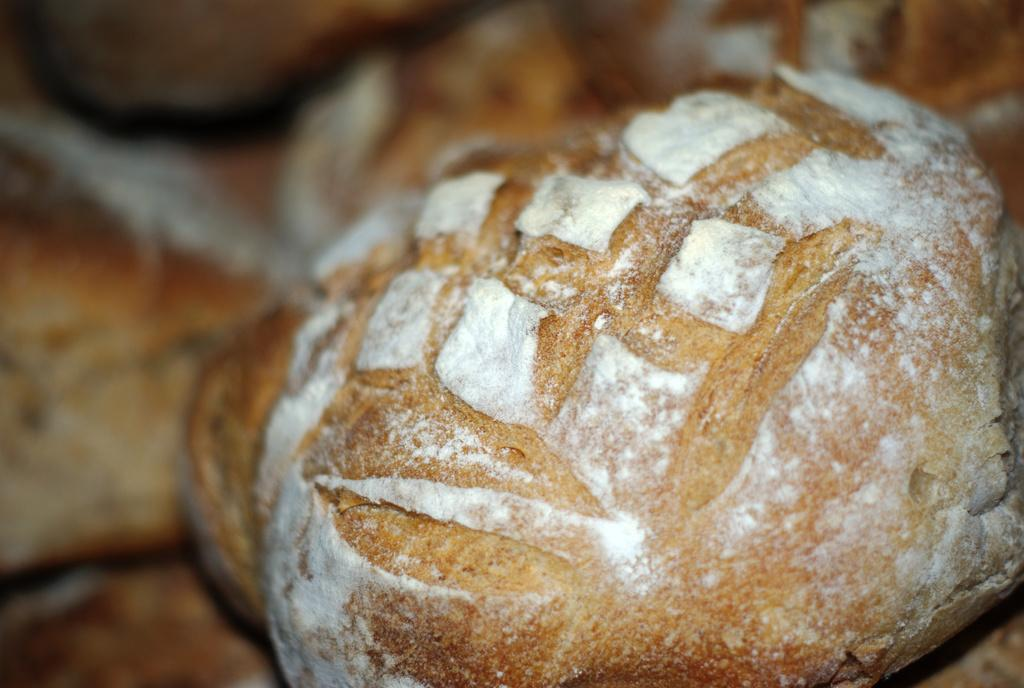What type of food item is visible in the image? The food item resembles bread. Can you describe the background of the image? The background of the image is blurry. How much money does the beggar have in the image? There is no beggar present in the image, so it is not possible to determine how much money they might have. 